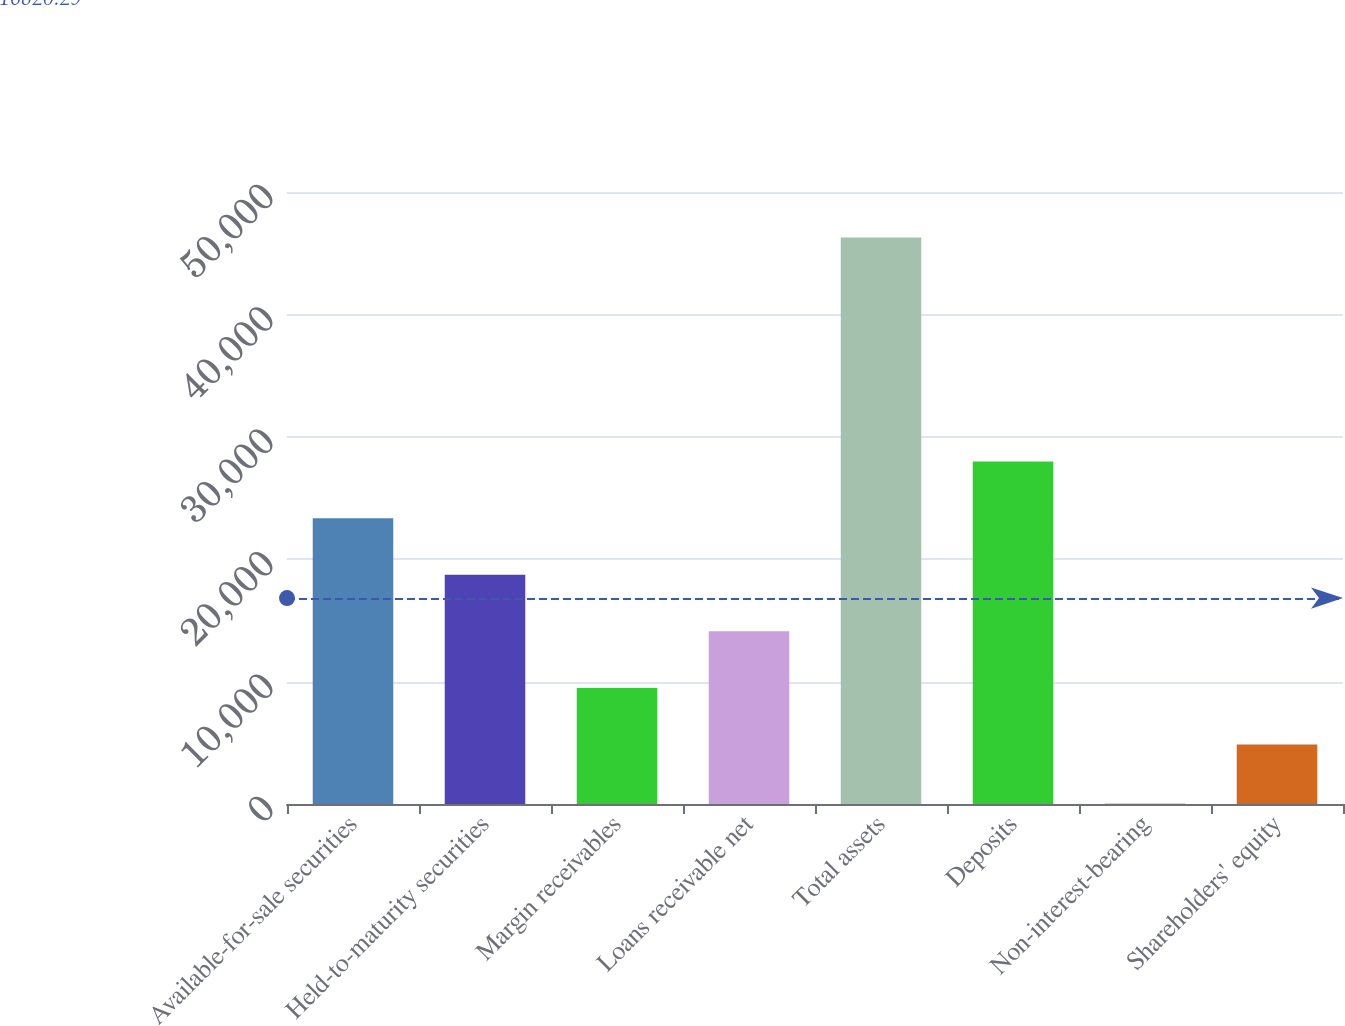<chart> <loc_0><loc_0><loc_500><loc_500><bar_chart><fcel>Available-for-sale securities<fcel>Held-to-maturity securities<fcel>Margin receivables<fcel>Loans receivable net<fcel>Total assets<fcel>Deposits<fcel>Non-interest-bearing<fcel>Shareholders' equity<nl><fcel>23351.2<fcel>18727.4<fcel>9479.8<fcel>14103.6<fcel>46280<fcel>27975<fcel>42<fcel>4856<nl></chart> 